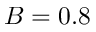<formula> <loc_0><loc_0><loc_500><loc_500>B = 0 . 8</formula> 